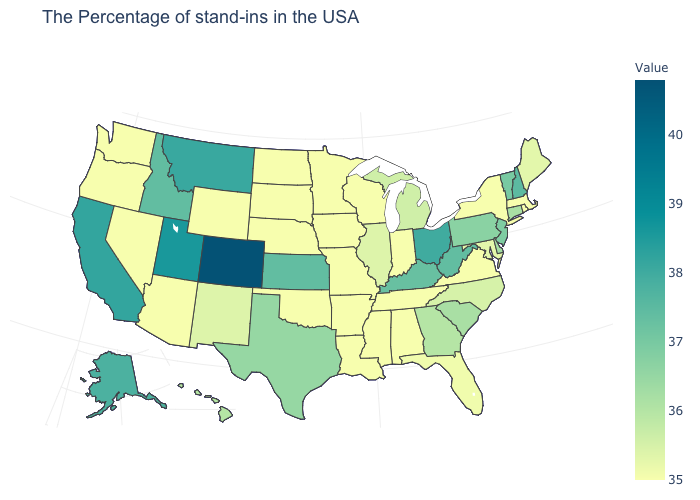Is the legend a continuous bar?
Answer briefly. Yes. Does New Jersey have the highest value in the Northeast?
Give a very brief answer. No. Which states hav the highest value in the MidWest?
Answer briefly. Ohio. Is the legend a continuous bar?
Answer briefly. Yes. Does the map have missing data?
Give a very brief answer. No. Which states have the lowest value in the MidWest?
Be succinct. Indiana, Wisconsin, Missouri, Minnesota, Iowa, Nebraska, South Dakota, North Dakota. Is the legend a continuous bar?
Concise answer only. Yes. 